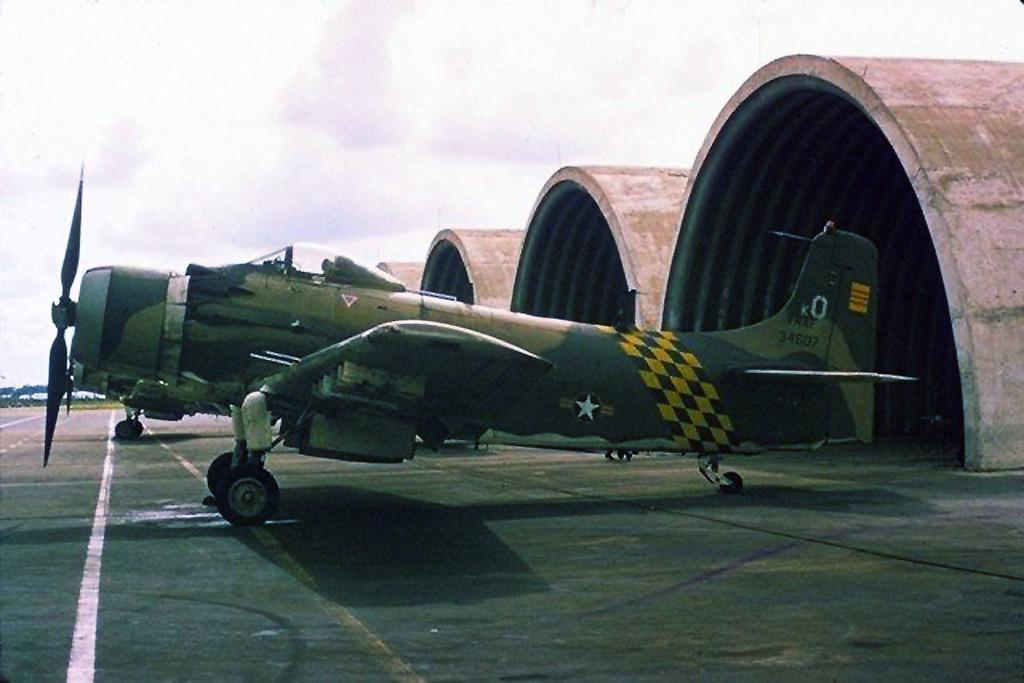<image>
Relay a brief, clear account of the picture shown. an old military plane in front of a hangar has k0 on the tail 